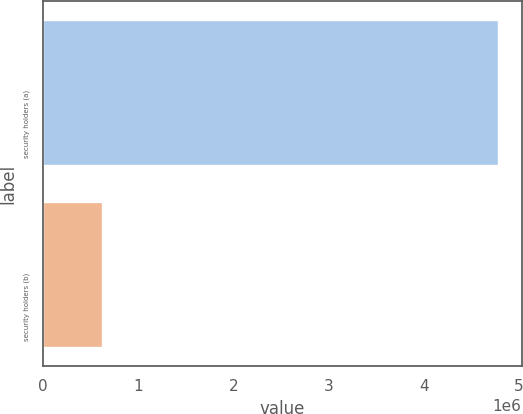Convert chart. <chart><loc_0><loc_0><loc_500><loc_500><bar_chart><fcel>security holders (a)<fcel>security holders (b)<nl><fcel>4.78704e+06<fcel>628328<nl></chart> 